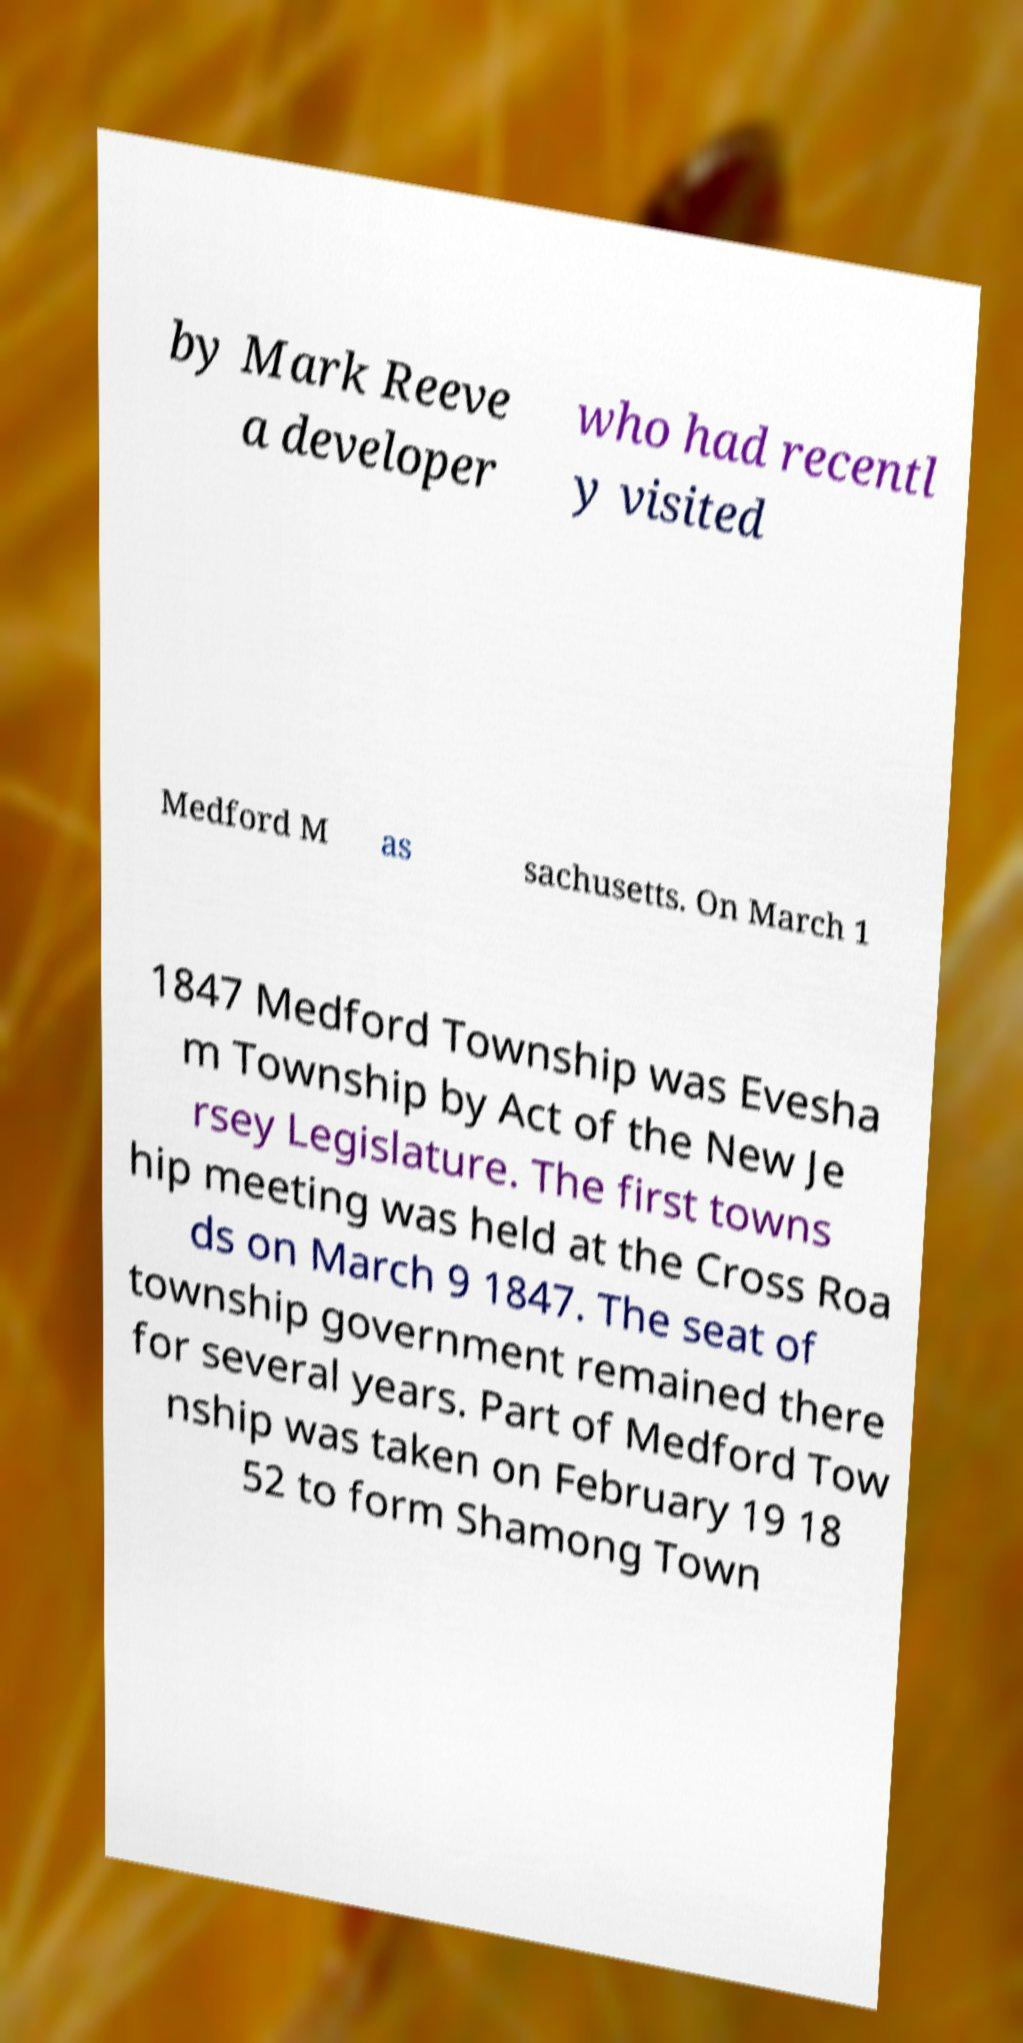For documentation purposes, I need the text within this image transcribed. Could you provide that? by Mark Reeve a developer who had recentl y visited Medford M as sachusetts. On March 1 1847 Medford Township was Evesha m Township by Act of the New Je rsey Legislature. The first towns hip meeting was held at the Cross Roa ds on March 9 1847. The seat of township government remained there for several years. Part of Medford Tow nship was taken on February 19 18 52 to form Shamong Town 